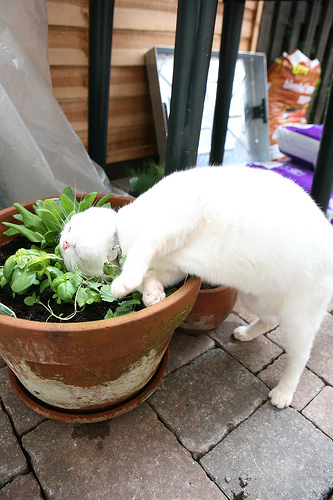What's the plant in? The plant is in a pot. 